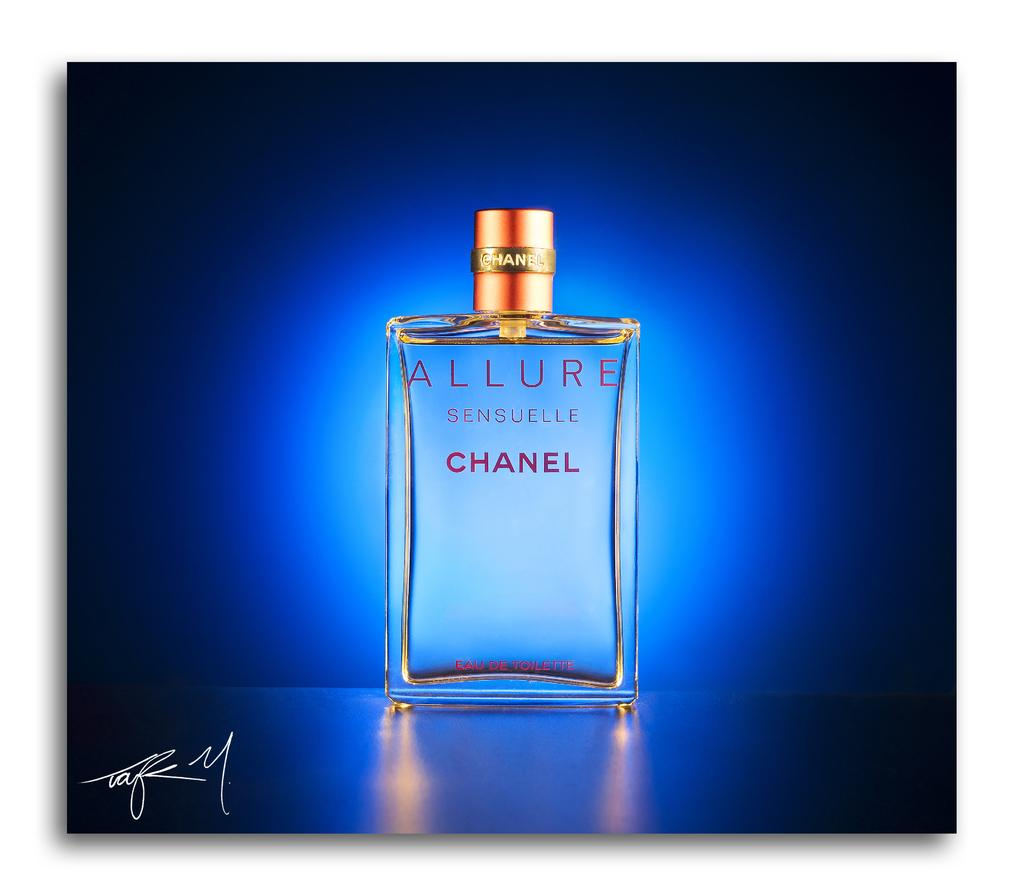What is the main object in the image? There is a perfume bottle in the image. Can you describe the perfume bottle in more detail? Unfortunately, the facts provided do not give any additional details about the perfume bottle. Is there anything else in the image besides the perfume bottle? The facts provided do not mention any other objects or elements in the image. How many cows are present in the image? There are no cows present in the image; it features a perfume bottle. Is there any blood visible in the image? There is no blood visible in the image; it features a perfume bottle. 